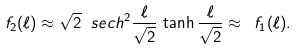<formula> <loc_0><loc_0><loc_500><loc_500>f _ { 2 } ( \ell ) \approx \sqrt { 2 } \ s e c h ^ { 2 } \frac { \ell } { \sqrt { 2 } } \, \tanh \frac { \ell } { \sqrt { 2 } } \approx \ f _ { 1 } ( \ell ) .</formula> 